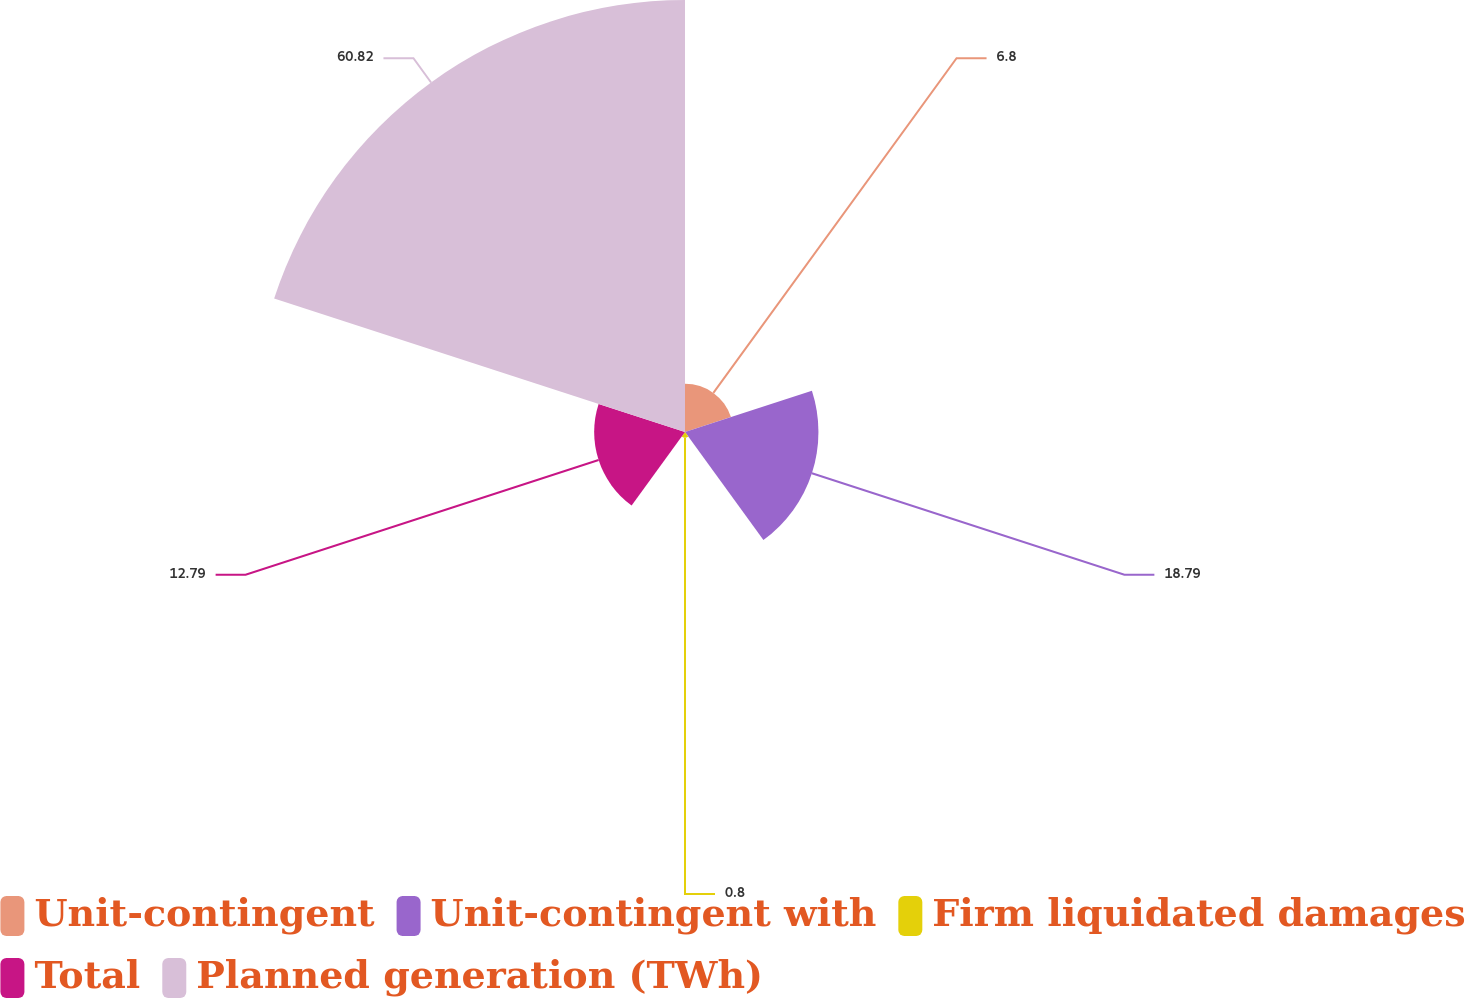Convert chart to OTSL. <chart><loc_0><loc_0><loc_500><loc_500><pie_chart><fcel>Unit-contingent<fcel>Unit-contingent with<fcel>Firm liquidated damages<fcel>Total<fcel>Planned generation (TWh)<nl><fcel>6.8%<fcel>18.79%<fcel>0.8%<fcel>12.79%<fcel>60.83%<nl></chart> 